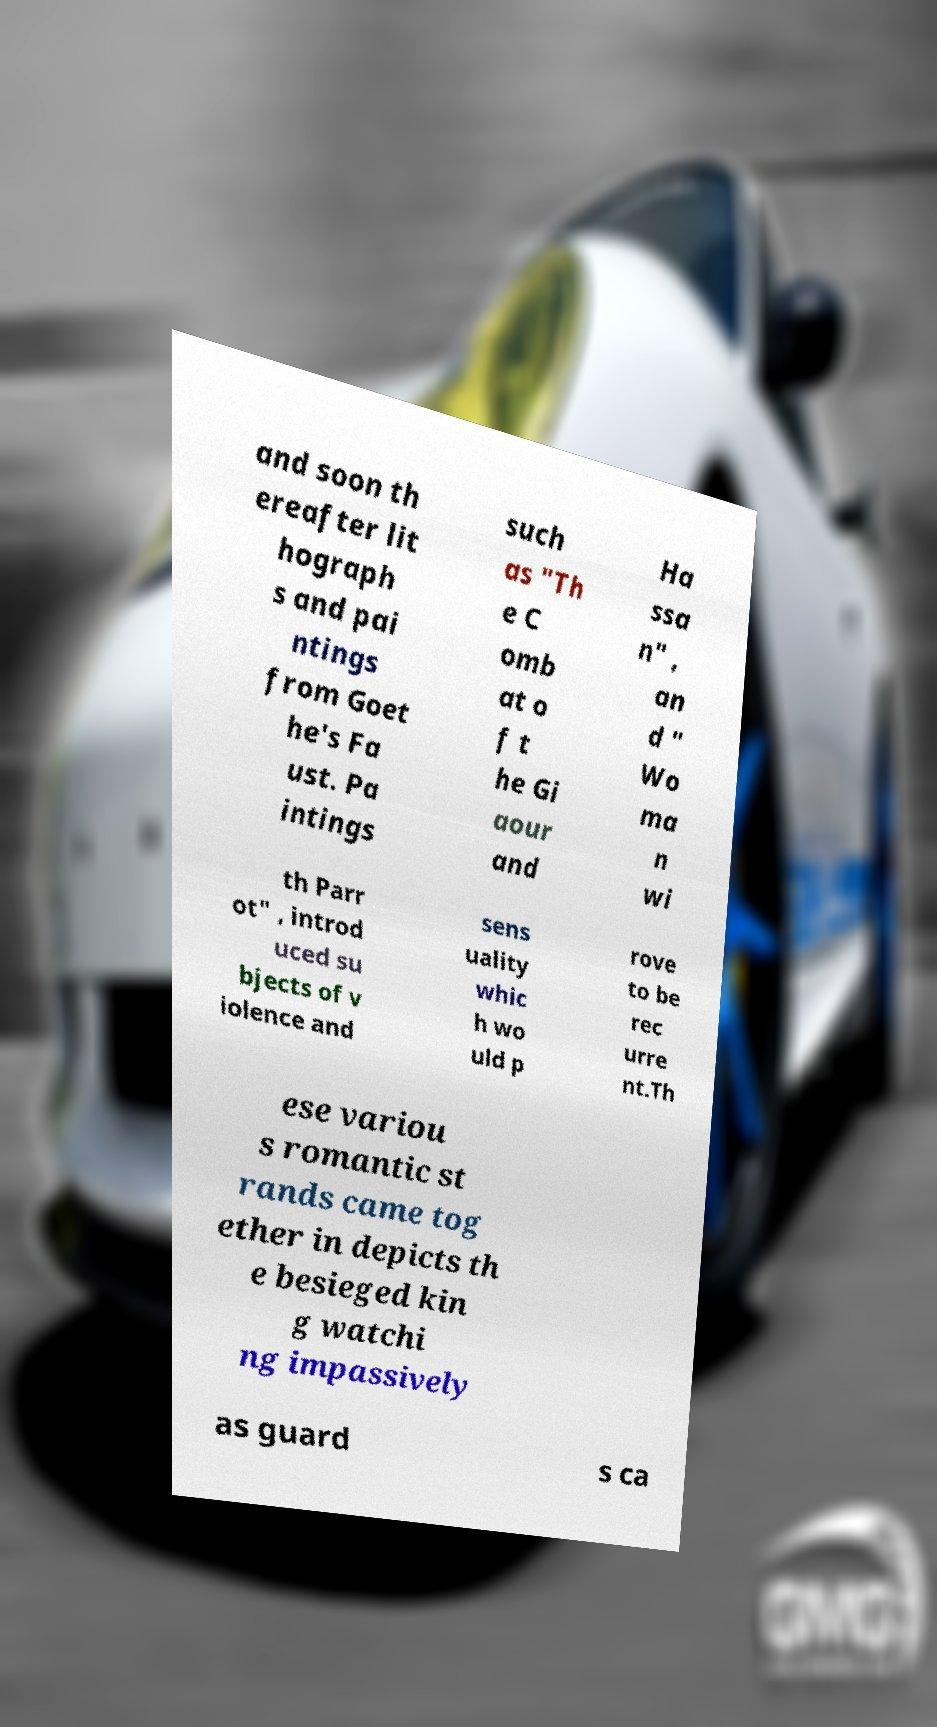Please read and relay the text visible in this image. What does it say? and soon th ereafter lit hograph s and pai ntings from Goet he's Fa ust. Pa intings such as "Th e C omb at o f t he Gi aour and Ha ssa n" , an d " Wo ma n wi th Parr ot" , introd uced su bjects of v iolence and sens uality whic h wo uld p rove to be rec urre nt.Th ese variou s romantic st rands came tog ether in depicts th e besieged kin g watchi ng impassively as guard s ca 